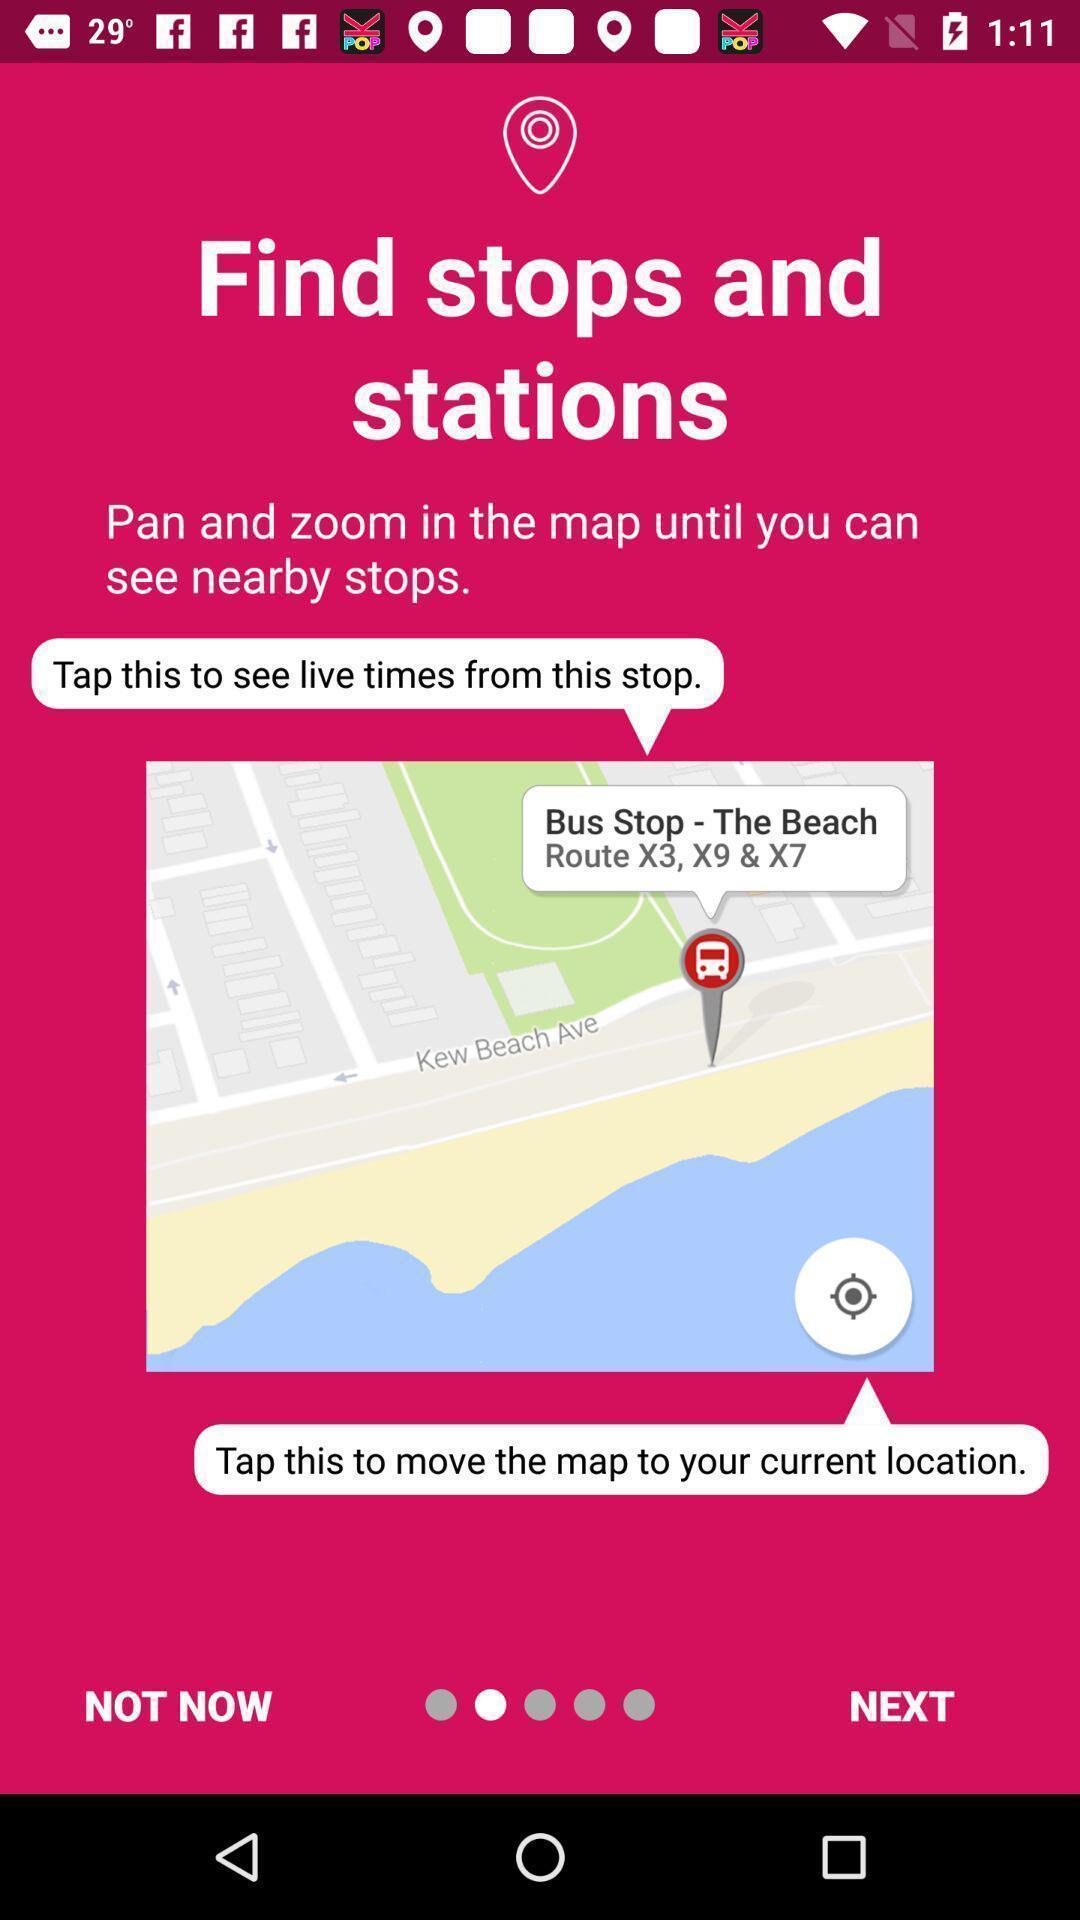Describe this image in words. Welcome page displaying to find stops in an navigation app. 